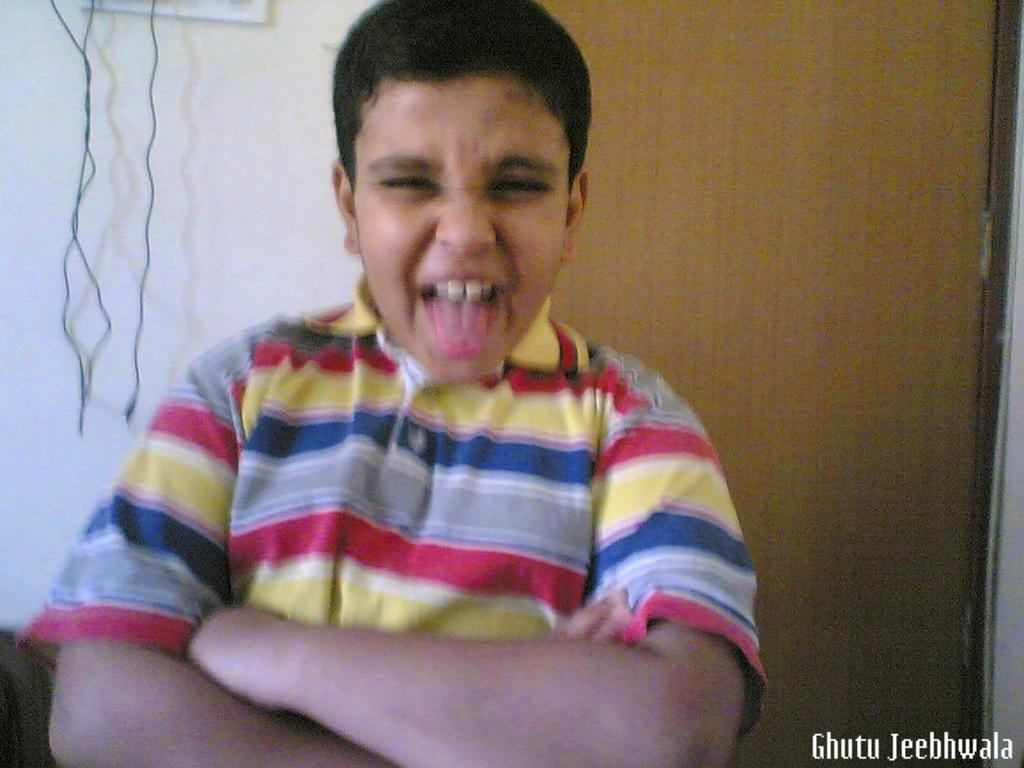What is the main subject of the image? There is a boy in the image. What is the boy wearing? The boy is wearing a t-shirt. Can you describe the quality of the image? The image is slightly blurry. Is there any additional information or markings on the image? Yes, there is a watermark in the image. What type of music is the boy listening to in the image? There is no indication of music or any audio source in the image, so it cannot be determined from the image. 